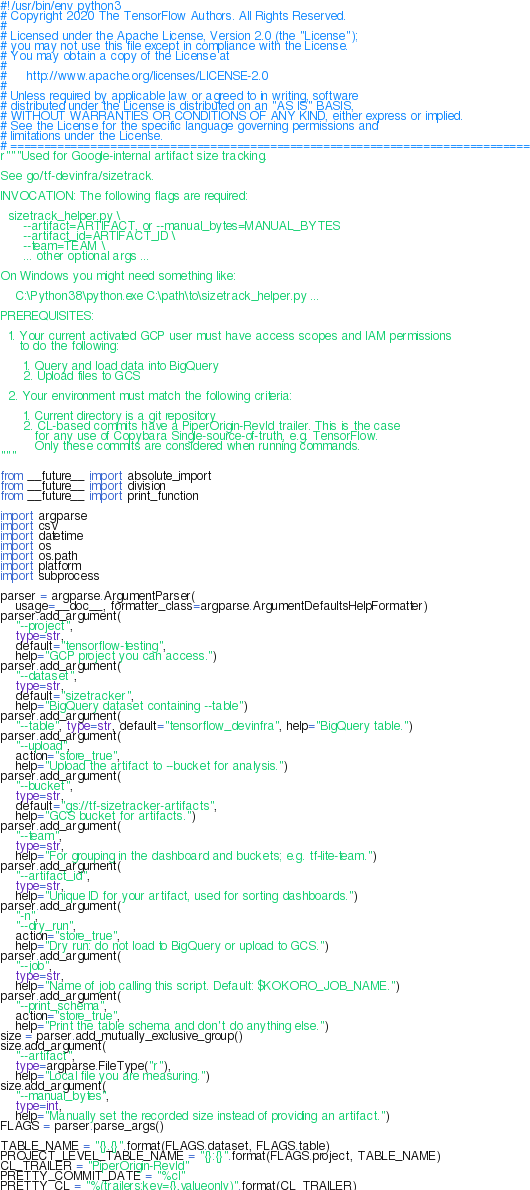Convert code to text. <code><loc_0><loc_0><loc_500><loc_500><_Python_>#!/usr/bin/env python3
# Copyright 2020 The TensorFlow Authors. All Rights Reserved.
#
# Licensed under the Apache License, Version 2.0 (the "License");
# you may not use this file except in compliance with the License.
# You may obtain a copy of the License at
#
#     http://www.apache.org/licenses/LICENSE-2.0
#
# Unless required by applicable law or agreed to in writing, software
# distributed under the License is distributed on an "AS IS" BASIS,
# WITHOUT WARRANTIES OR CONDITIONS OF ANY KIND, either express or implied.
# See the License for the specific language governing permissions and
# limitations under the License.
# ==============================================================================
r"""Used for Google-internal artifact size tracking.

See go/tf-devinfra/sizetrack.

INVOCATION: The following flags are required:

  sizetrack_helper.py \
      --artifact=ARTIFACT, or --manual_bytes=MANUAL_BYTES
      --artifact_id=ARTIFACT_ID \
      --team=TEAM \
      ... other optional args ...

On Windows you might need something like:

    C:\Python38\python.exe C:\path\to\sizetrack_helper.py ...

PREREQUISITES:

  1. Your current activated GCP user must have access scopes and IAM permissions
     to do the following:

      1. Query and load data into BigQuery
      2. Upload files to GCS

  2. Your environment must match the following criteria:

      1. Current directory is a git repository
      2. CL-based commits have a PiperOrigin-RevId trailer. This is the case
         for any use of Copybara Single-source-of-truth, e.g. TensorFlow.
         Only these commits are considered when running commands.
"""

from __future__ import absolute_import
from __future__ import division
from __future__ import print_function

import argparse
import csv
import datetime
import os
import os.path
import platform
import subprocess

parser = argparse.ArgumentParser(
    usage=__doc__, formatter_class=argparse.ArgumentDefaultsHelpFormatter)
parser.add_argument(
    "--project",
    type=str,
    default="tensorflow-testing",
    help="GCP project you can access.")
parser.add_argument(
    "--dataset",
    type=str,
    default="sizetracker",
    help="BigQuery dataset containing --table")
parser.add_argument(
    "--table", type=str, default="tensorflow_devinfra", help="BigQuery table.")
parser.add_argument(
    "--upload",
    action="store_true",
    help="Upload the artifact to --bucket for analysis.")
parser.add_argument(
    "--bucket",
    type=str,
    default="gs://tf-sizetracker-artifacts",
    help="GCS bucket for artifacts.")
parser.add_argument(
    "--team",
    type=str,
    help="For grouping in the dashboard and buckets; e.g. tf-lite-team.")
parser.add_argument(
    "--artifact_id",
    type=str,
    help="Unique ID for your artifact, used for sorting dashboards.")
parser.add_argument(
    "-n",
    "--dry_run",
    action="store_true",
    help="Dry run: do not load to BigQuery or upload to GCS.")
parser.add_argument(
    "--job",
    type=str,
    help="Name of job calling this script. Default: $KOKORO_JOB_NAME.")
parser.add_argument(
    "--print_schema",
    action="store_true",
    help="Print the table schema and don't do anything else.")
size = parser.add_mutually_exclusive_group()
size.add_argument(
    "--artifact",
    type=argparse.FileType("r"),
    help="Local file you are measuring.")
size.add_argument(
    "--manual_bytes",
    type=int,
    help="Manually set the recorded size instead of providing an artifact.")
FLAGS = parser.parse_args()

TABLE_NAME = "{}.{}".format(FLAGS.dataset, FLAGS.table)
PROJECT_LEVEL_TABLE_NAME = "{}:{}".format(FLAGS.project, TABLE_NAME)
CL_TRAILER = "PiperOrigin-RevId"
PRETTY_COMMIT_DATE = "%cI"
PRETTY_CL = "%(trailers:key={},valueonly)".format(CL_TRAILER)</code> 